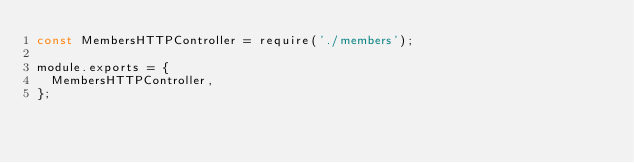<code> <loc_0><loc_0><loc_500><loc_500><_JavaScript_>const MembersHTTPController = require('./members');

module.exports = {
  MembersHTTPController,
};
</code> 